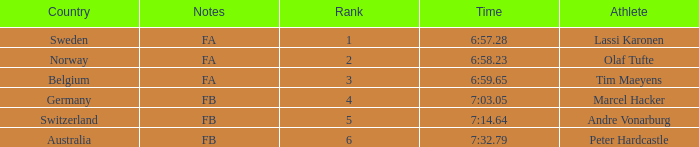What is the lowest rank for Andre Vonarburg, when the notes are FB? 5.0. 